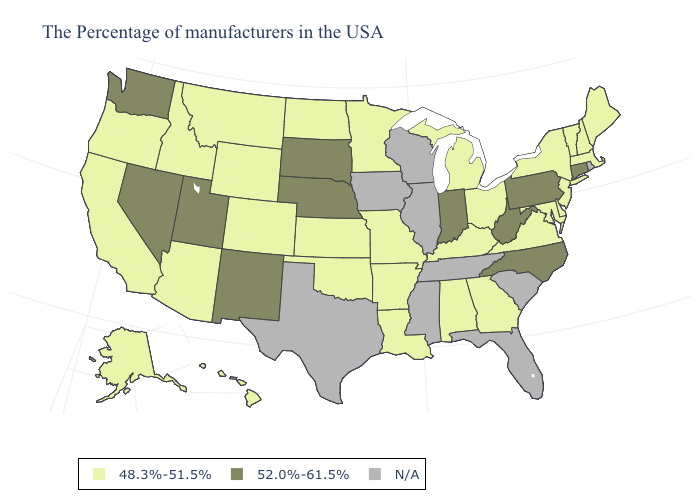Name the states that have a value in the range N/A?
Keep it brief. Rhode Island, South Carolina, Florida, Tennessee, Wisconsin, Illinois, Mississippi, Iowa, Texas. Which states have the lowest value in the MidWest?
Be succinct. Ohio, Michigan, Missouri, Minnesota, Kansas, North Dakota. Name the states that have a value in the range 52.0%-61.5%?
Answer briefly. Connecticut, Pennsylvania, North Carolina, West Virginia, Indiana, Nebraska, South Dakota, New Mexico, Utah, Nevada, Washington. Name the states that have a value in the range 52.0%-61.5%?
Be succinct. Connecticut, Pennsylvania, North Carolina, West Virginia, Indiana, Nebraska, South Dakota, New Mexico, Utah, Nevada, Washington. What is the highest value in states that border Tennessee?
Concise answer only. 52.0%-61.5%. Name the states that have a value in the range 48.3%-51.5%?
Write a very short answer. Maine, Massachusetts, New Hampshire, Vermont, New York, New Jersey, Delaware, Maryland, Virginia, Ohio, Georgia, Michigan, Kentucky, Alabama, Louisiana, Missouri, Arkansas, Minnesota, Kansas, Oklahoma, North Dakota, Wyoming, Colorado, Montana, Arizona, Idaho, California, Oregon, Alaska, Hawaii. Name the states that have a value in the range 52.0%-61.5%?
Be succinct. Connecticut, Pennsylvania, North Carolina, West Virginia, Indiana, Nebraska, South Dakota, New Mexico, Utah, Nevada, Washington. Does the first symbol in the legend represent the smallest category?
Answer briefly. Yes. What is the lowest value in states that border Alabama?
Be succinct. 48.3%-51.5%. Name the states that have a value in the range 48.3%-51.5%?
Short answer required. Maine, Massachusetts, New Hampshire, Vermont, New York, New Jersey, Delaware, Maryland, Virginia, Ohio, Georgia, Michigan, Kentucky, Alabama, Louisiana, Missouri, Arkansas, Minnesota, Kansas, Oklahoma, North Dakota, Wyoming, Colorado, Montana, Arizona, Idaho, California, Oregon, Alaska, Hawaii. What is the value of Illinois?
Give a very brief answer. N/A. Name the states that have a value in the range N/A?
Concise answer only. Rhode Island, South Carolina, Florida, Tennessee, Wisconsin, Illinois, Mississippi, Iowa, Texas. 